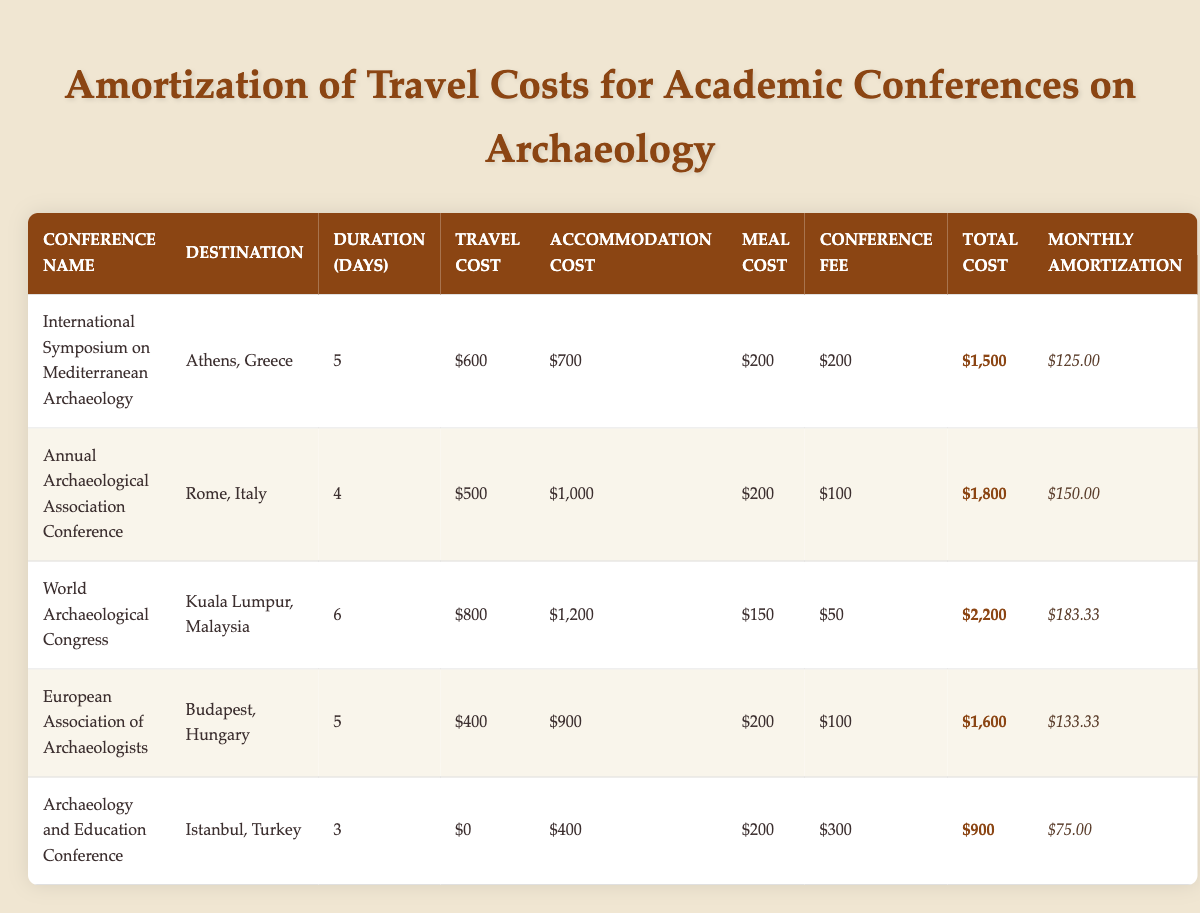What is the total cost of attending the World Archaeological Congress? The total cost for the World Archaeological Congress is $2,200, as stated in the table under "Total Cost" for that conference.
Answer: $2,200 How much is the monthly amortization for the Annual Archaeological Association Conference? The monthly amortization for the Annual Archaeological Association Conference is $150.00, as shown in the "Monthly Amortization" column for this conference.
Answer: $150.00 Which conference has the highest total cost? The World Archaeological Congress has the highest total cost of $2,200 when compared to the other conferences listed in the table.
Answer: World Archaeological Congress What is the average total cost of all the conferences listed? To find the average total cost, sum up the total costs of all conferences: $1,500 + $1,800 + $2,200 + $1,600 + $900 = $8,000. Then divide by the number of conferences (5): $8,000 / 5 = $1,600.
Answer: $1,600 Does the Archaeology and Education Conference have a travel cost? No, the travel cost for the Archaeology and Education Conference is $0, as specified in the "Travel Cost" column.
Answer: No Which destination has the longest duration of the conference? The World Archaeological Congress in Kuala Lumpur, Malaysia, has the longest duration at 6 days compared to the other conferences.
Answer: Kuala Lumpur, Malaysia What is the difference between the total costs of the International Symposium on Mediterranean Archaeology and the European Association of Archaeologists? The total cost of the International Symposium on Mediterranean Archaeology is $1,500, and for the European Association of Archaeologists, it is $1,600. The difference is $1,600 - $1,500 = $100.
Answer: $100 How many conferences were held in European cities? Four conferences were held in European cities: Athens, Rome, Budapest, and Istanbul, making it a total of 4 conferences listed under European destinations.
Answer: 4 What are the combined accommodation costs for all conferences held in Turkey? The Archaeology and Education Conference in Istanbul has an accommodation cost of $400, while no travel cost was reported for this conference. Thus, the combined accommodation costs for conferences held in Turkey is $400.
Answer: $400 